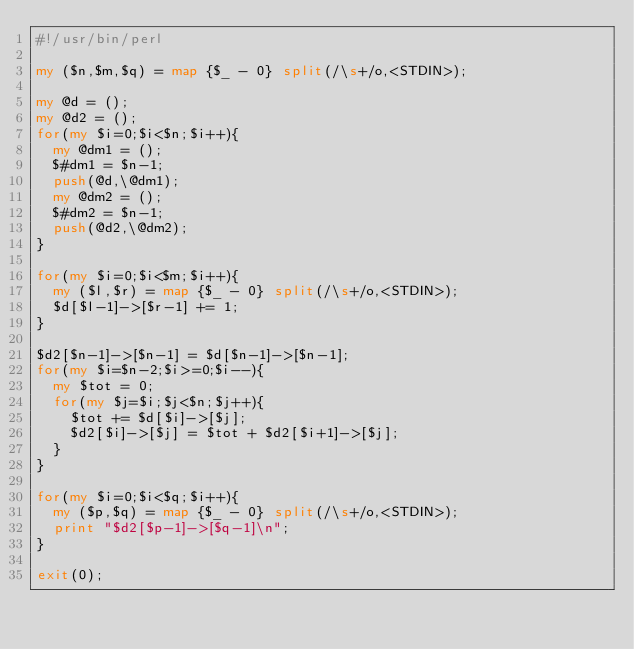Convert code to text. <code><loc_0><loc_0><loc_500><loc_500><_Perl_>#!/usr/bin/perl

my ($n,$m,$q) = map {$_ - 0} split(/\s+/o,<STDIN>);

my @d = ();
my @d2 = ();
for(my $i=0;$i<$n;$i++){
  my @dm1 = ();
  $#dm1 = $n-1;
  push(@d,\@dm1);
  my @dm2 = ();
  $#dm2 = $n-1;
  push(@d2,\@dm2);
}

for(my $i=0;$i<$m;$i++){
  my ($l,$r) = map {$_ - 0} split(/\s+/o,<STDIN>);
  $d[$l-1]->[$r-1] += 1;
}

$d2[$n-1]->[$n-1] = $d[$n-1]->[$n-1];
for(my $i=$n-2;$i>=0;$i--){
  my $tot = 0;
  for(my $j=$i;$j<$n;$j++){
    $tot += $d[$i]->[$j];
    $d2[$i]->[$j] = $tot + $d2[$i+1]->[$j];
  }
}

for(my $i=0;$i<$q;$i++){
  my ($p,$q) = map {$_ - 0} split(/\s+/o,<STDIN>);
  print "$d2[$p-1]->[$q-1]\n";
}

exit(0);

</code> 